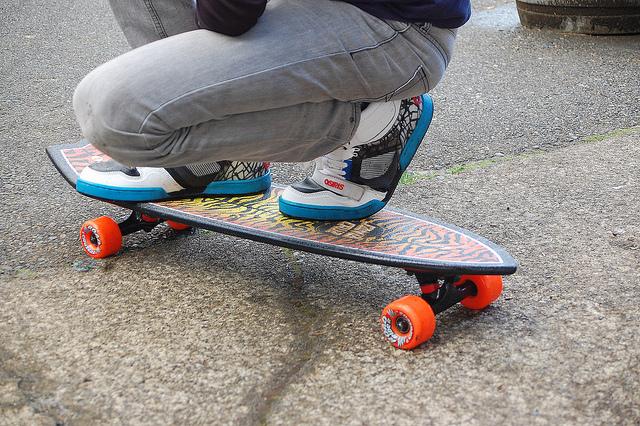What color are the wheels?
Short answer required. Orange. What color are the pants?
Short answer required. Gray. Are both feet on the skateboard?
Short answer required. Yes. 